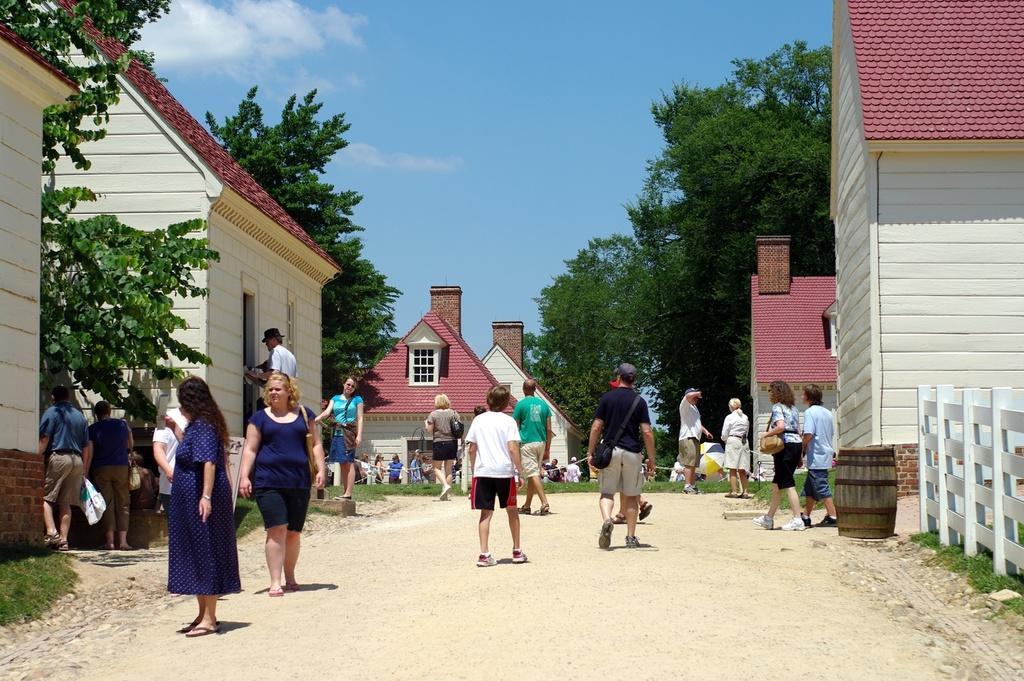Please provide a concise description of this image. In this image there is a road in the middle. On the road there are so many people walking on it. There are houses on either side of the road. At the top there is the sky. There are trees in between the houses. 